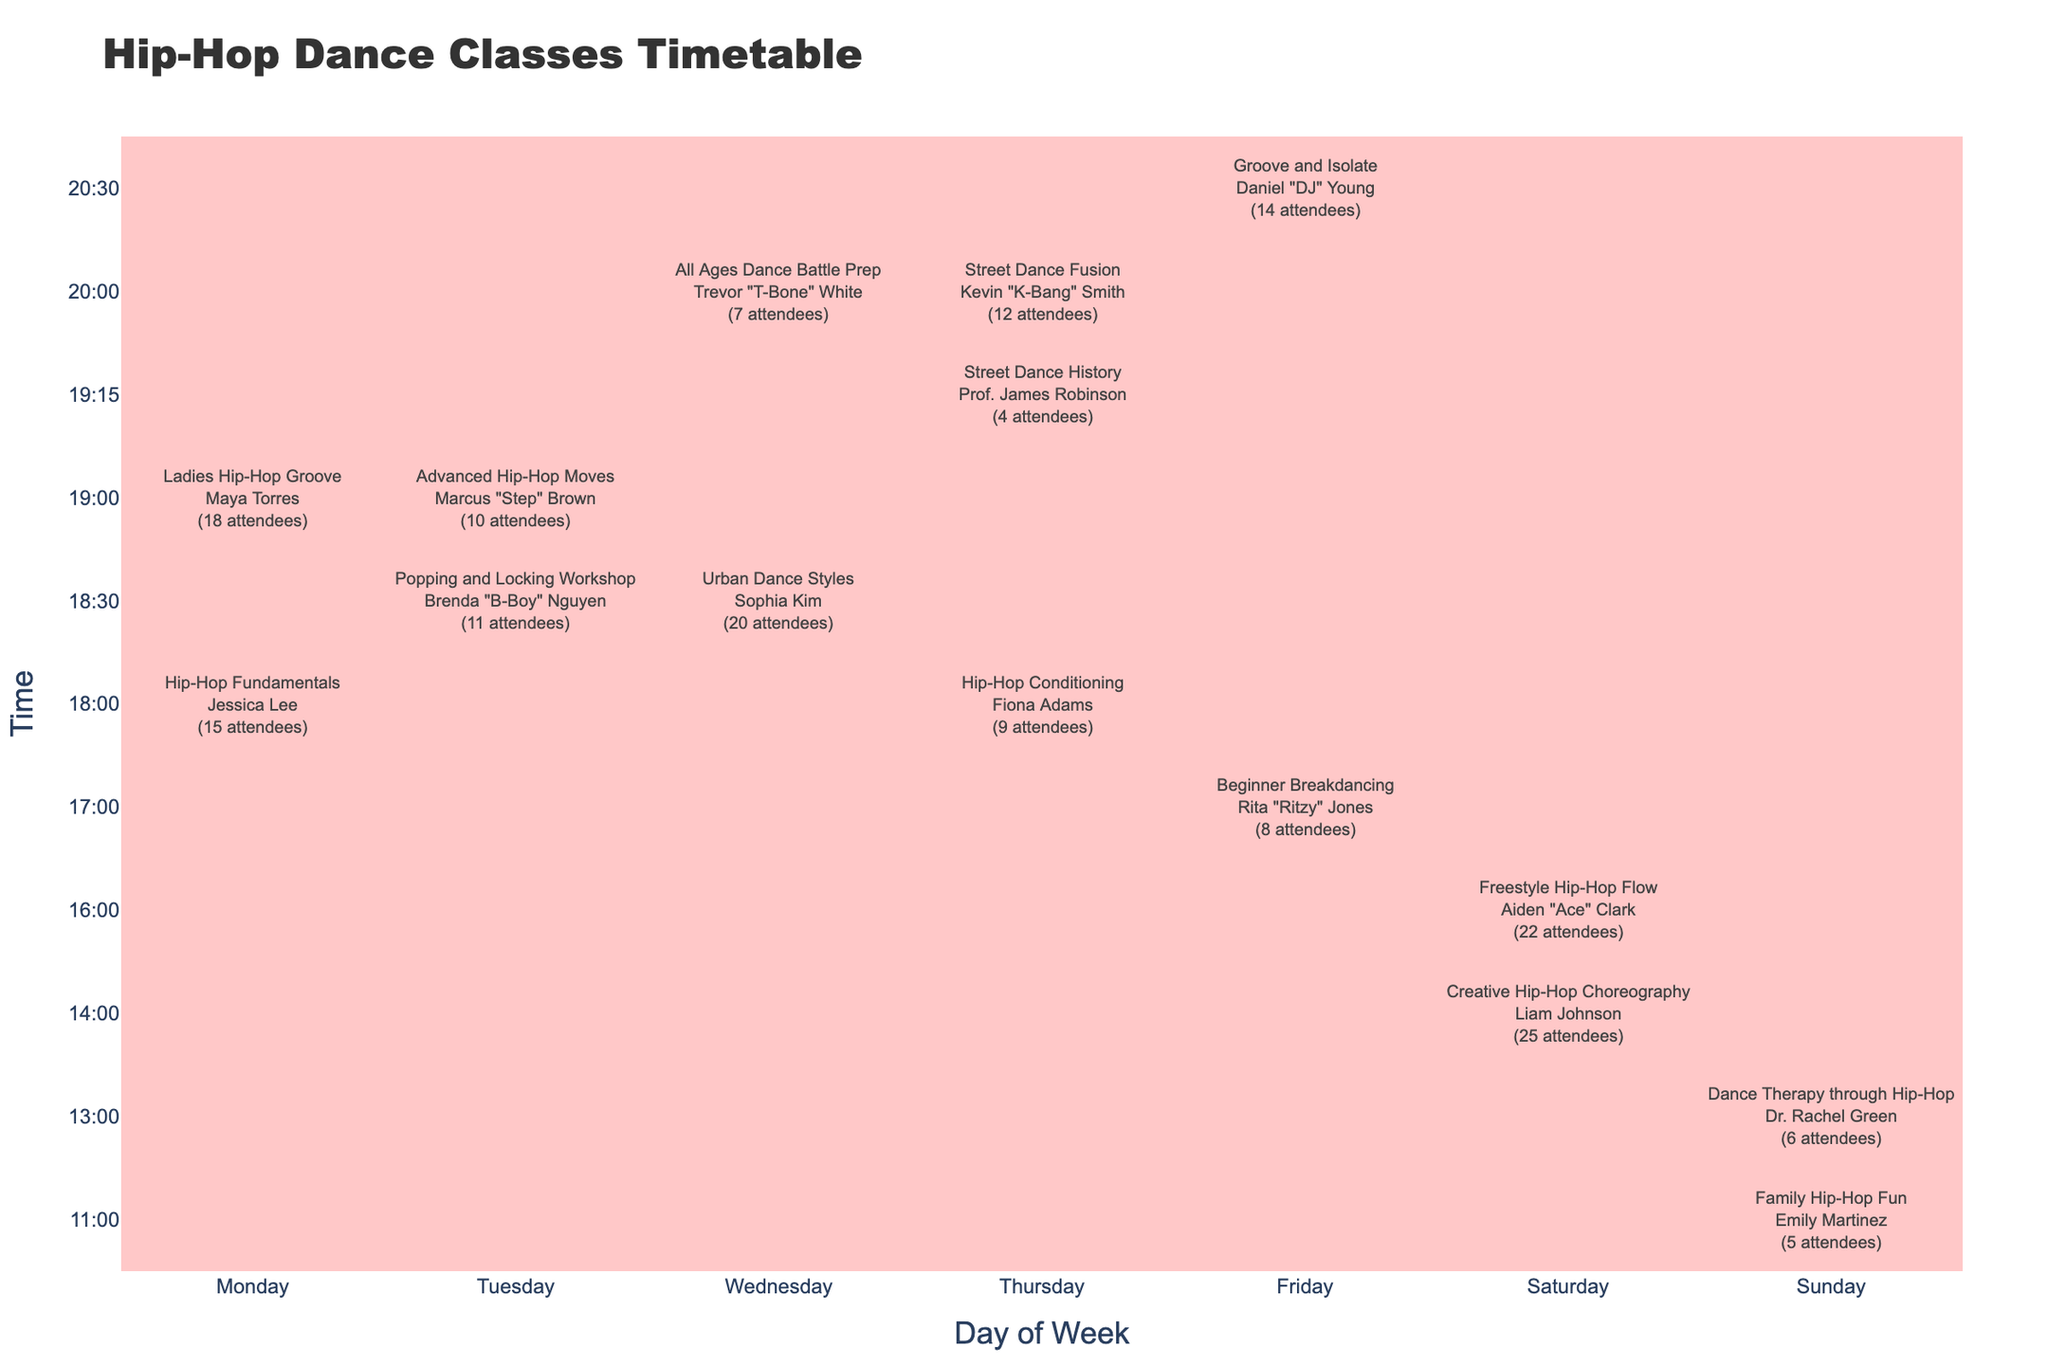What is the attendance count for the 'Urban Dance Styles' class? The table indicates the attendance count listed beside the 'Urban Dance Styles' class under Wednesday at 18:30, which shows 20 attendees.
Answer: 20 Which class has the highest attendance? To determine the class with the highest attendance, we look at the attendance counts for all classes. The 'Creative Hip-Hop Choreography' class has the highest count of 25 attendees.
Answer: Creative Hip-Hop Choreography On which day is the 'Ladies Hip-Hop Groove' class scheduled? The table shows that the 'Ladies Hip-Hop Groove' class is scheduled for Monday at 19:00, as indicated in the row corresponding to that class.
Answer: Monday What is the total attendance for all classes on Friday? The classes on Friday include 'Beginner Breakdancing' with 8 attendees and 'Groove and Isolate' with 14 attendees. Adding these together gives a total of 8 + 14 = 22 attendees on Friday.
Answer: 22 Is there a class on Sunday? By examining the table, we see two classes scheduled on Sunday: 'Family Hip-Hop Fun' at 11:00 with 5 attendees, and 'Dance Therapy through Hip-Hop' at 13:00 with 6 attendees. Therefore, there are classes on Sunday.
Answer: Yes Which class has the least attendance and what is the count? Looking through the attendance counts, the 'Street Dance History' class shows the lowest attendance of 4. This is the minimum value across all listed classes.
Answer: Street Dance History, 4 What is the average attendance across all classes? To find the average attendance, we first sum all the attendance counts: 15 + 10 + 20 + 12 + 8 + 25 + 5 + 18 + 7 + 9 + 22 + 11 + 4 + 14 + 6 =  186. Then, divide this total by the number of classes (15): 186 / 15 = 12.4. So the average attendance is approximately 12.4.
Answer: 12.4 Which instructor teaches the class with the second highest attendance? The class with the second highest attendance is 'Freestyle Hip-Hop Flow' with 22 attendees. The instructor for this class is Aiden "Ace" Clark.
Answer: Aiden "Ace" Clark How many classes are scheduled for Wednesday? The table lists 2 classes on Wednesday: 'Urban Dance Styles' and 'All Ages Dance Battle Prep'. Therefore, there are a total of 2 classes on Wednesday.
Answer: 2 